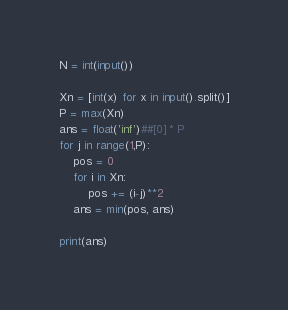Convert code to text. <code><loc_0><loc_0><loc_500><loc_500><_Python_>N = int(input())

Xn = [int(x) for x in input().split()]
P = max(Xn)
ans = float('inf')##[0] * P
for j in range(1,P):
    pos = 0
    for i in Xn:
        pos += (i-j)**2
    ans = min(pos, ans)

print(ans)
</code> 